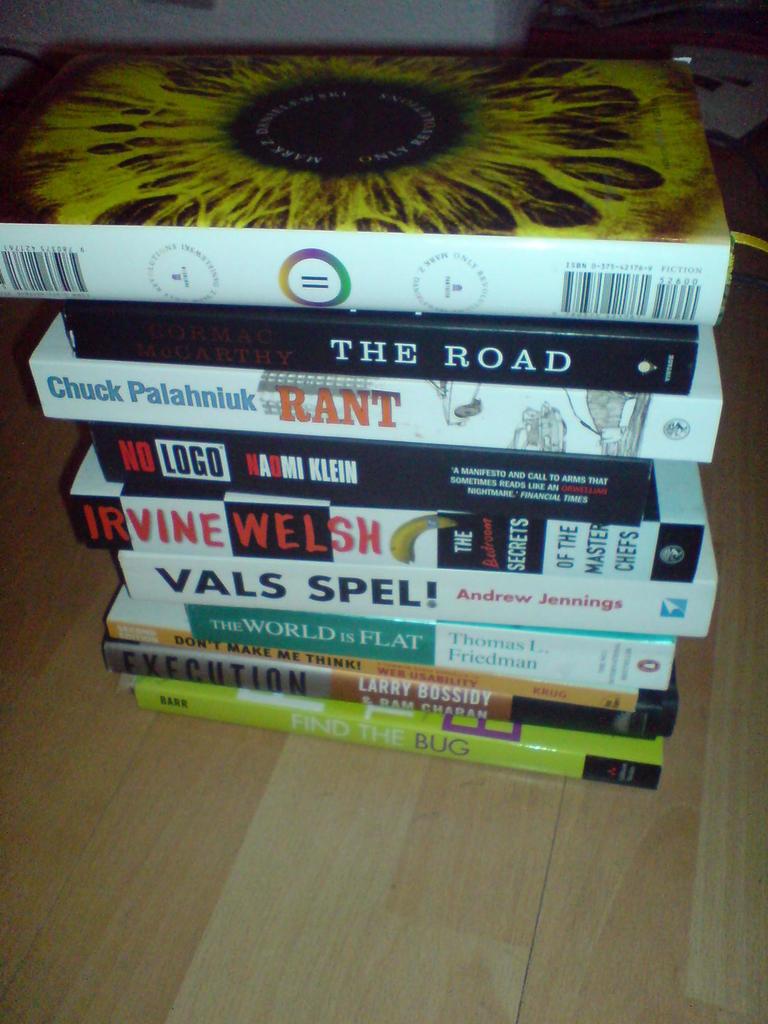What is the title of the second book from the top?
Ensure brevity in your answer.  The road. 